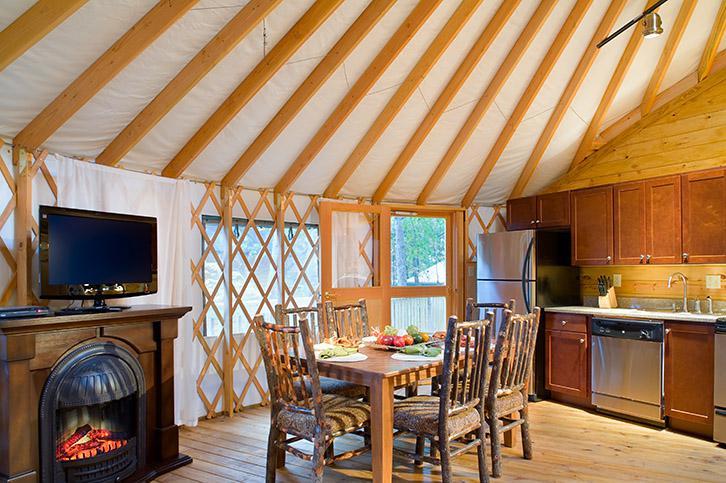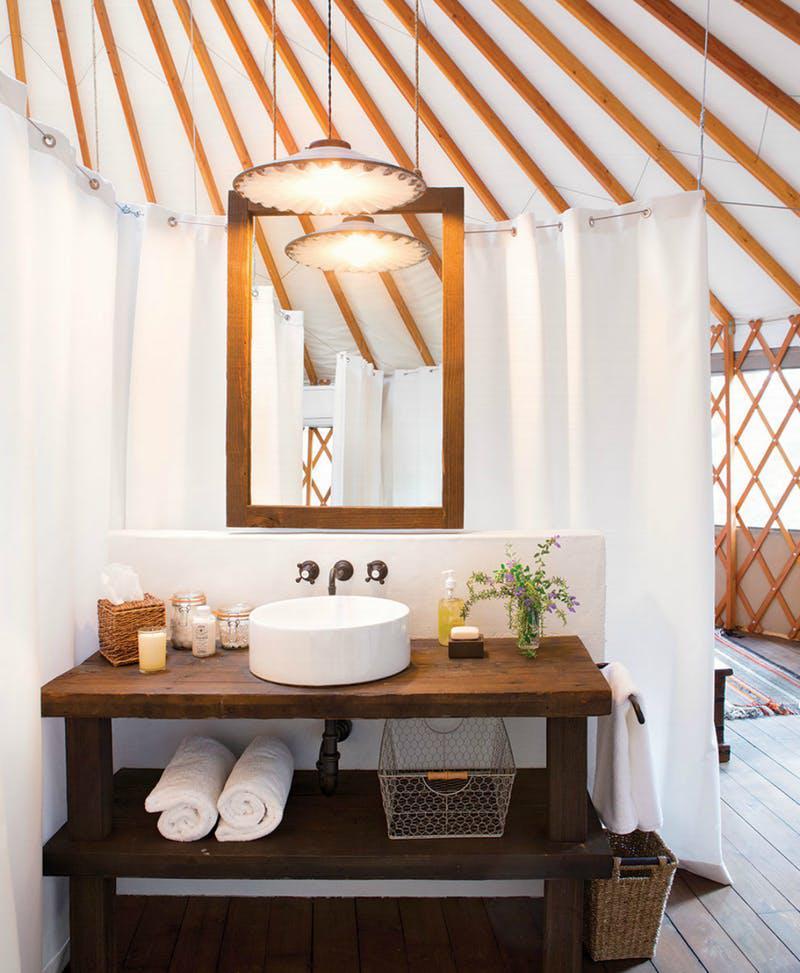The first image is the image on the left, the second image is the image on the right. Considering the images on both sides, is "There is wooden floor in both images." valid? Answer yes or no. Yes. The first image is the image on the left, the second image is the image on the right. Examine the images to the left and right. Is the description "The image on the right contains at least one set of bunk beds." accurate? Answer yes or no. No. 